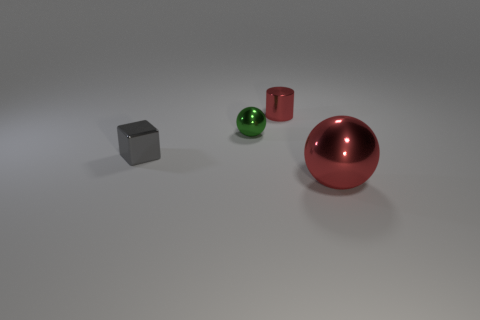Add 3 shiny cubes. How many objects exist? 7 Subtract all cylinders. How many objects are left? 3 Subtract 0 green cylinders. How many objects are left? 4 Subtract all small green things. Subtract all big cyan blocks. How many objects are left? 3 Add 1 large red objects. How many large red objects are left? 2 Add 2 big yellow rubber objects. How many big yellow rubber objects exist? 2 